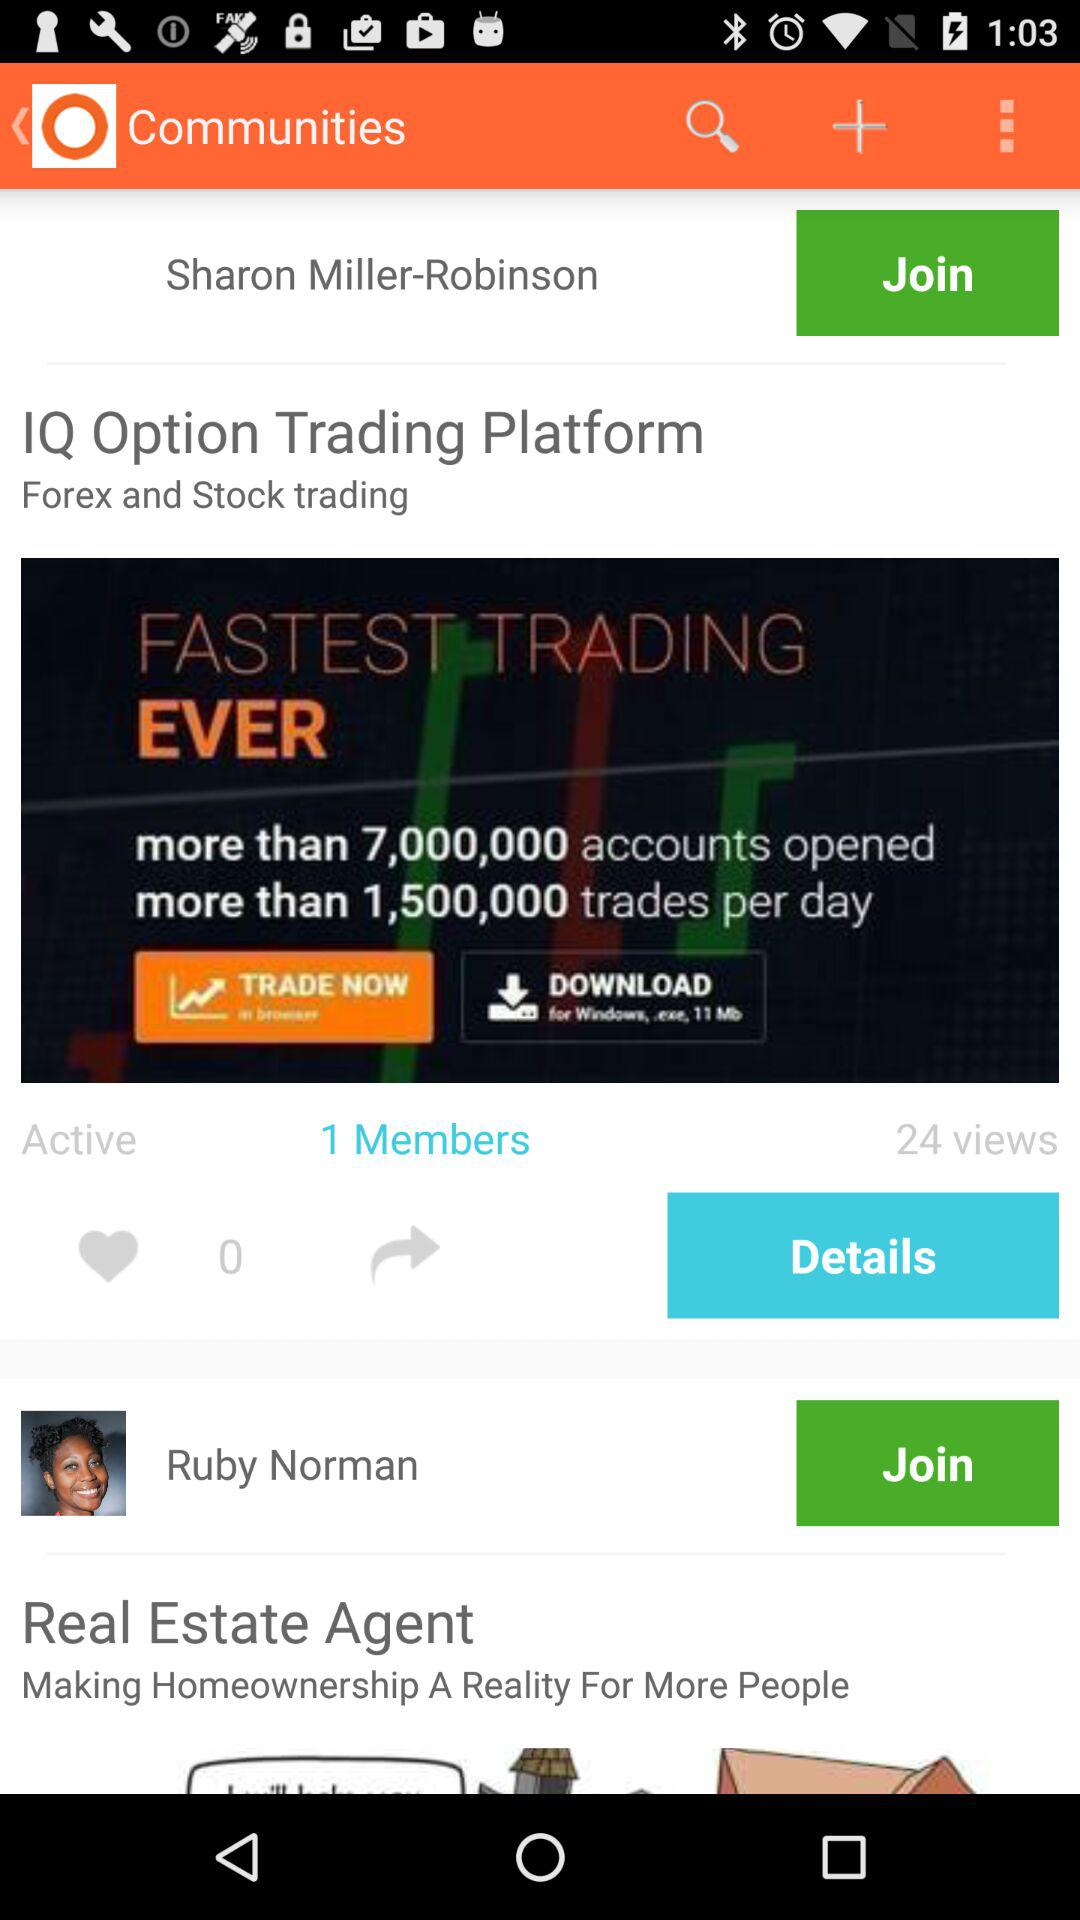How many members are there? There is 1 member. 